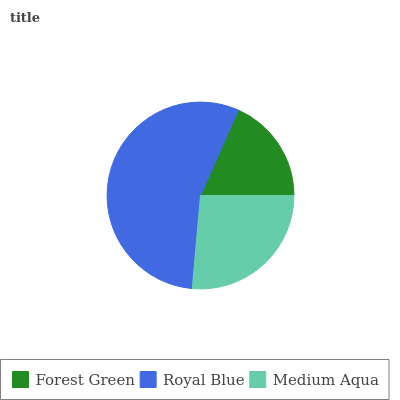Is Forest Green the minimum?
Answer yes or no. Yes. Is Royal Blue the maximum?
Answer yes or no. Yes. Is Medium Aqua the minimum?
Answer yes or no. No. Is Medium Aqua the maximum?
Answer yes or no. No. Is Royal Blue greater than Medium Aqua?
Answer yes or no. Yes. Is Medium Aqua less than Royal Blue?
Answer yes or no. Yes. Is Medium Aqua greater than Royal Blue?
Answer yes or no. No. Is Royal Blue less than Medium Aqua?
Answer yes or no. No. Is Medium Aqua the high median?
Answer yes or no. Yes. Is Medium Aqua the low median?
Answer yes or no. Yes. Is Forest Green the high median?
Answer yes or no. No. Is Forest Green the low median?
Answer yes or no. No. 